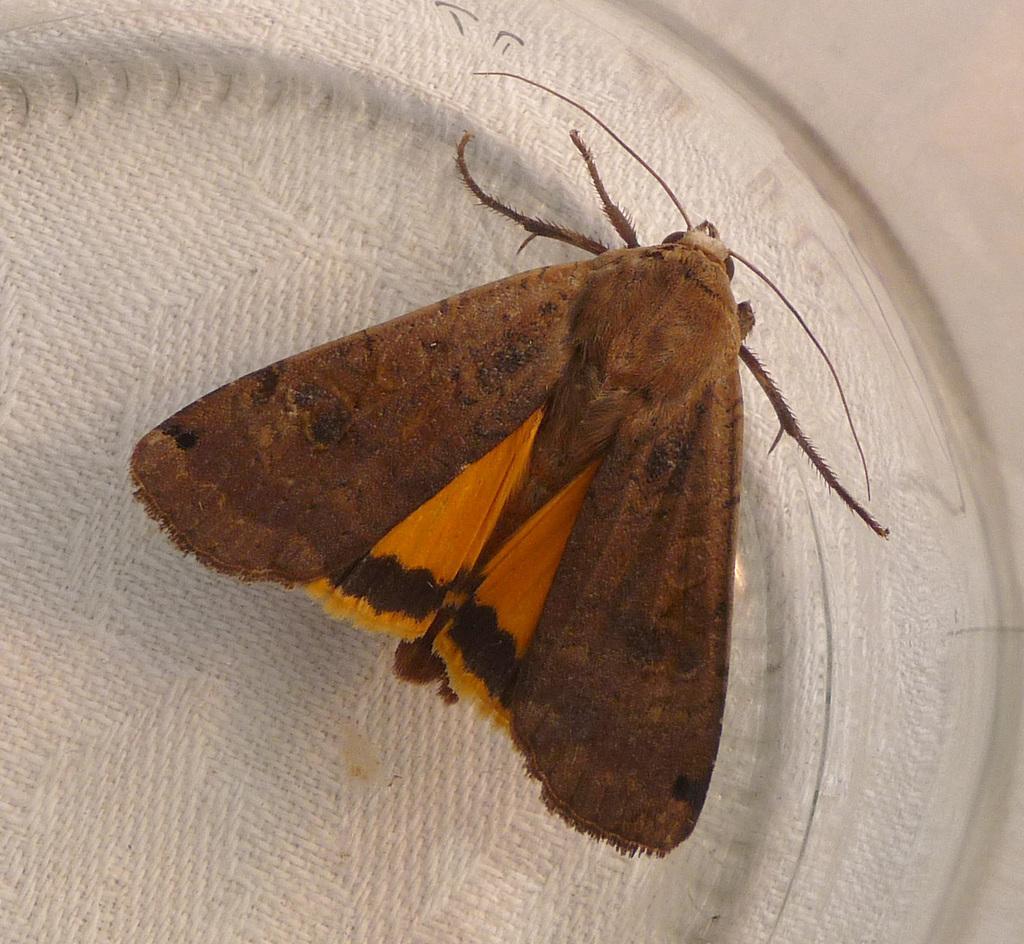Can you describe this image briefly? There is a brown and yellow color butterfly on a white surface. 